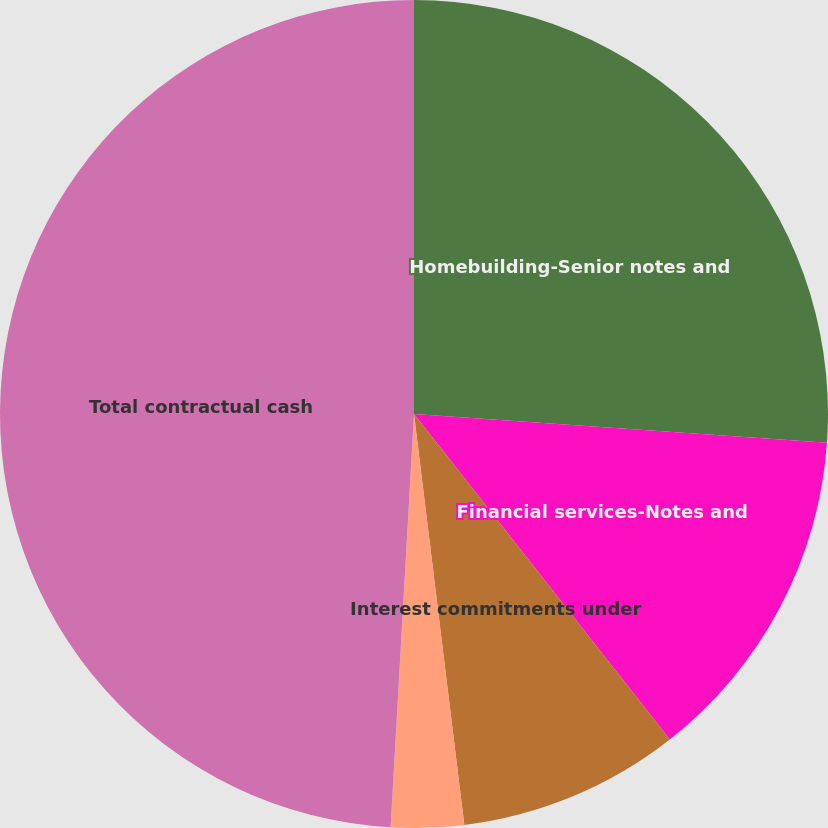<chart> <loc_0><loc_0><loc_500><loc_500><pie_chart><fcel>Homebuilding-Senior notes and<fcel>Financial services-Notes and<fcel>Interest commitments under<fcel>Operating leases<fcel>Total contractual cash<nl><fcel>26.11%<fcel>13.29%<fcel>8.66%<fcel>2.84%<fcel>49.1%<nl></chart> 